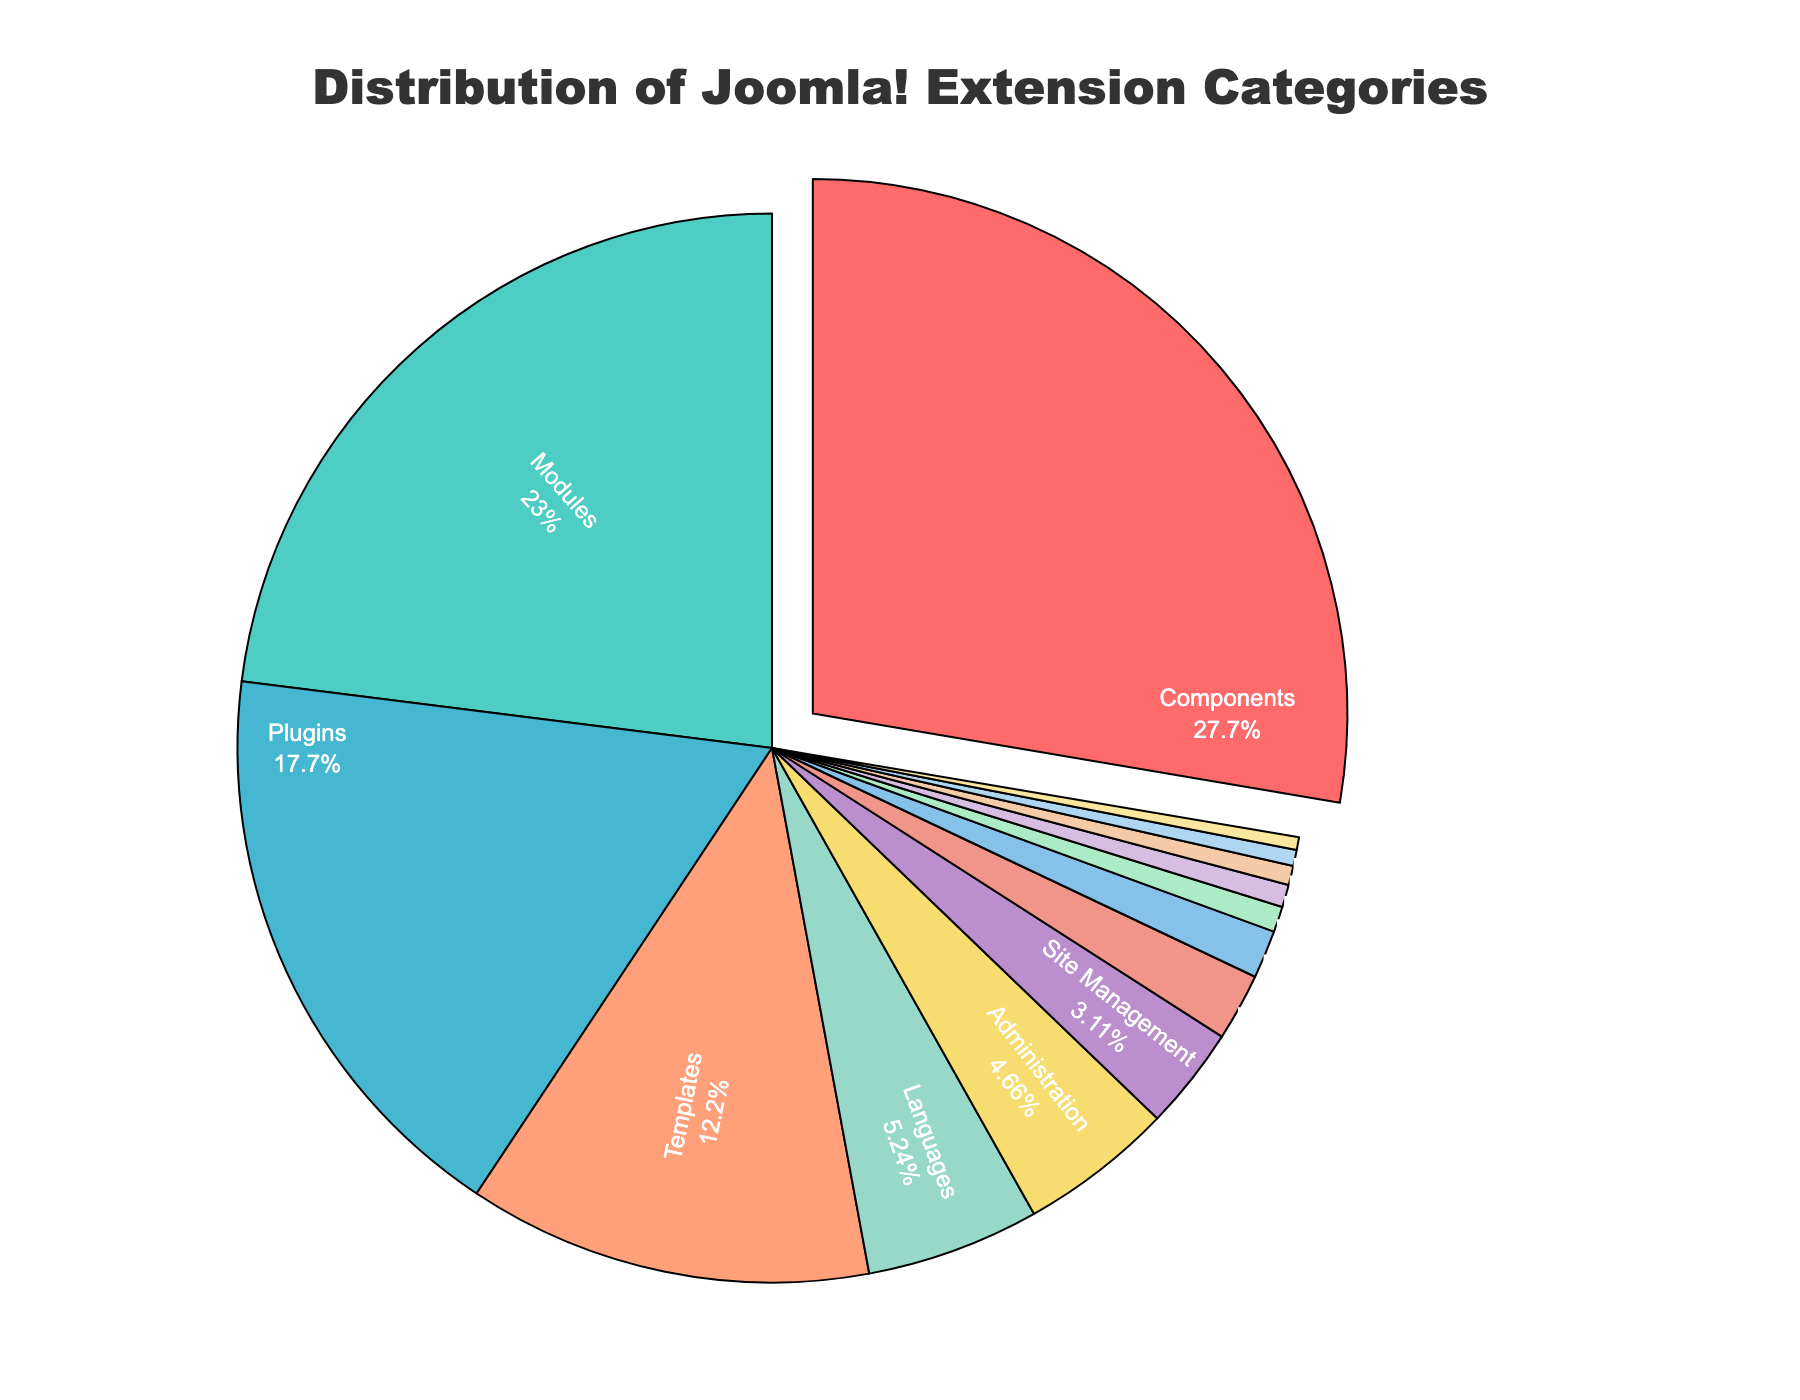Which category has the highest percentage in the distribution? By visually inspecting the pie chart, notice that the largest segment is labeled "Components". It also has the highest percentage displayed on it.
Answer: Components What is the combined percentage of Components, Modules, and Plugins? First, identify the percentages for Components (28.5%), Modules (23.7%), and Plugins (18.2%). Add these values together: 28.5 + 23.7 + 18.2 = 70.4.
Answer: 70.4 Which category has a lower percentage, Security or E-commerce? Look at the segments in the pie chart labeled "Security" and "E-commerce". Security is 2.1% and E-commerce is 0.8%. Since 0.8% is less than 2.1%, E-commerce has a lower percentage.
Answer: E-commerce How much larger is the Templates category compared to the Languages category in percentage points? Identify the percentage for Templates (12.6%) and for Languages (5.4%). Subtract the percentage of Languages from Templates: 12.6 - 5.4 = 7.2.
Answer: 7.2 What is the average percentage of Administration, Site Management, and Security categories? Determine the percentages for Administration (4.8%), Site Management (3.2%), and Security (2.1%). Compute their average by adding these values and dividing by 3: (4.8 + 3.2 + 2.1) / 3 = 3.37.
Answer: 3.37 Which category has the smallest percentage and what is its value? Identify the smallest segment in the pie chart. The segment labeled "Backup and Migration" is the smallest with a percentage of 0.4%.
Answer: Backup and Migration, 0.4 Is the combined percentage of Content Creation and Social Media Integration greater than the percentage of SEO? Note the percentages of Content Creation (0.7%) and Social Media Integration (0.6%). Add them: 0.7 + 0.6 = 1.3%. Compare this with SEO which is 1.5%. Since 1.3% is less than 1.5%, the combined percentage is not greater.
Answer: No Between which two categories is the difference in their percentages exactly 1.0? Observe the segments and compare the percentages. The difference between Administration (4.8%) and Site Management (3.2%) is exactly 1.6%, which is the closest. However, there is no exact 1.0% difference. Also, between Languages (5.4%) and Administration (4.8%) the difference is 0.6%. Therefore, this question is based on refining the data comparison but might not have a strict 1.0%.
Answer: None What percentage of the total do categories below 1% collectively account for? Identify categories below 1%: E-commerce (0.8%), Content Creation (0.7%), Social Media Integration (0.6%), Database Tools (0.5%), and Backup and Migration (0.4%). Sum their percentages: 0.8 + 0.7 + 0.6 + 0.5 + 0.4 = 3.0%.
Answer: 3.0 